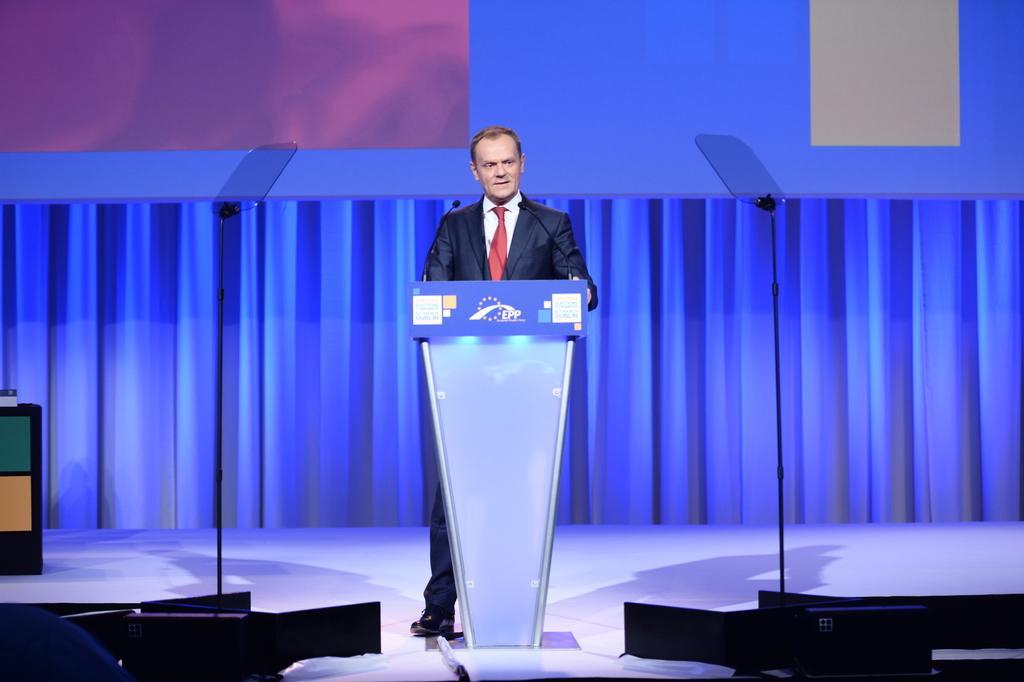Could you give a brief overview of what you see in this image? In this image we can see a person standing in front of the podium, there are two mics on the podium and there are some other objects on the surface, in the background we can see a screen and curtains. 